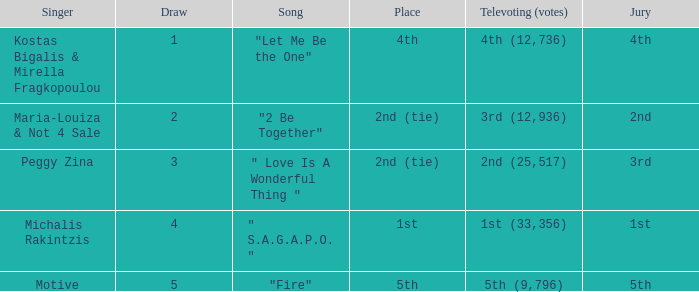The song "2 Be Together" had what jury? 2nd. 